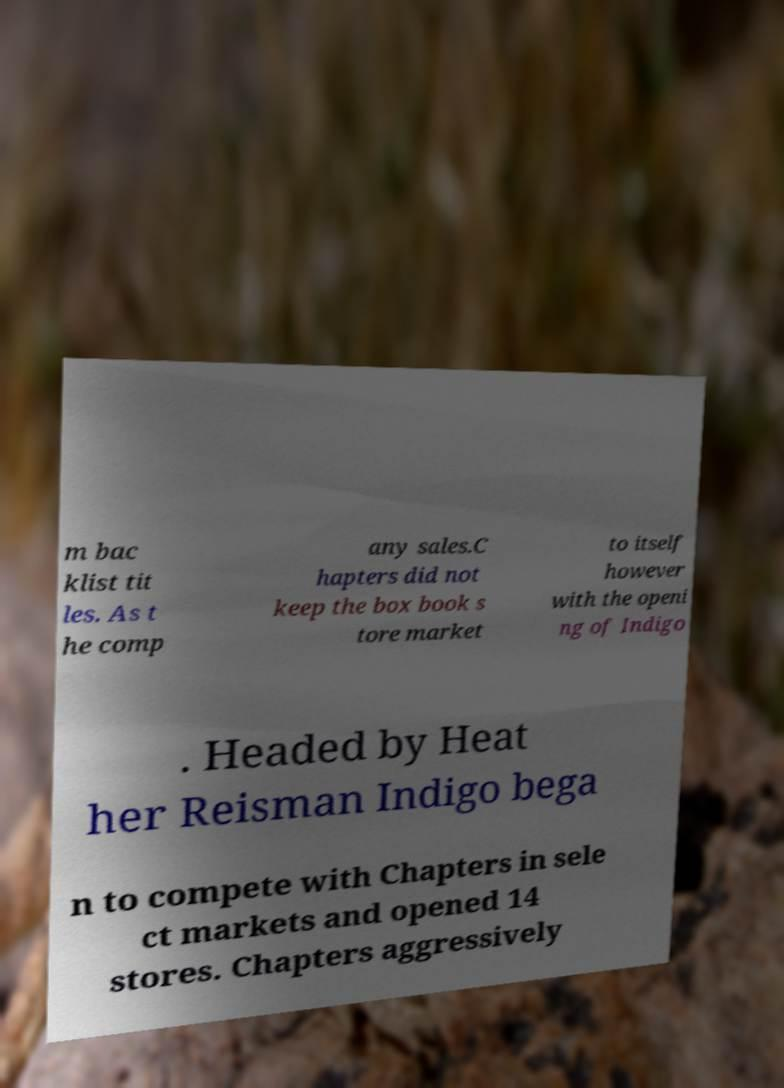I need the written content from this picture converted into text. Can you do that? m bac klist tit les. As t he comp any sales.C hapters did not keep the box book s tore market to itself however with the openi ng of Indigo . Headed by Heat her Reisman Indigo bega n to compete with Chapters in sele ct markets and opened 14 stores. Chapters aggressively 